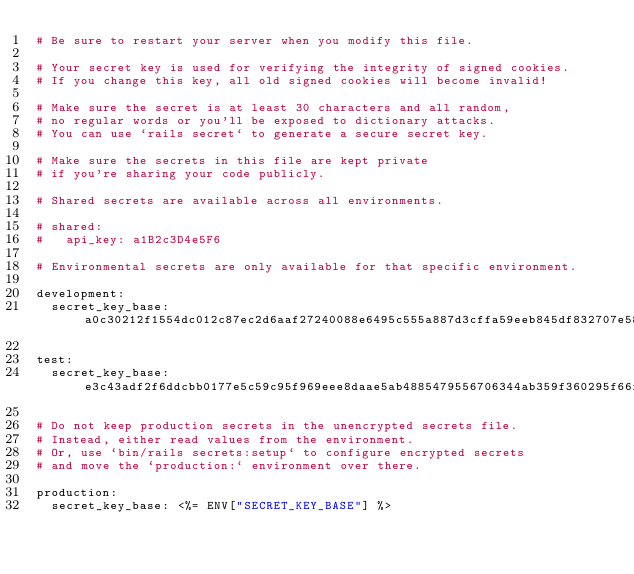<code> <loc_0><loc_0><loc_500><loc_500><_YAML_># Be sure to restart your server when you modify this file.

# Your secret key is used for verifying the integrity of signed cookies.
# If you change this key, all old signed cookies will become invalid!

# Make sure the secret is at least 30 characters and all random,
# no regular words or you'll be exposed to dictionary attacks.
# You can use `rails secret` to generate a secure secret key.

# Make sure the secrets in this file are kept private
# if you're sharing your code publicly.

# Shared secrets are available across all environments.

# shared:
#   api_key: a1B2c3D4e5F6

# Environmental secrets are only available for that specific environment.

development:
  secret_key_base: a0c30212f1554dc012c87ec2d6aaf27240088e6495c555a887d3cffa59eeb845df832707e584cddad33a9a5c8e6c7801eea746d2c2a62fa17ea8d8357177ab13

test:
  secret_key_base: e3c43adf2f6ddcbb0177e5c59c95f969eee8daae5ab4885479556706344ab359f360295f66f51b46f575b5b447ba3cfaa1cc2679efb048da63f81333541e8acb

# Do not keep production secrets in the unencrypted secrets file.
# Instead, either read values from the environment.
# Or, use `bin/rails secrets:setup` to configure encrypted secrets
# and move the `production:` environment over there.

production:
  secret_key_base: <%= ENV["SECRET_KEY_BASE"] %>
</code> 